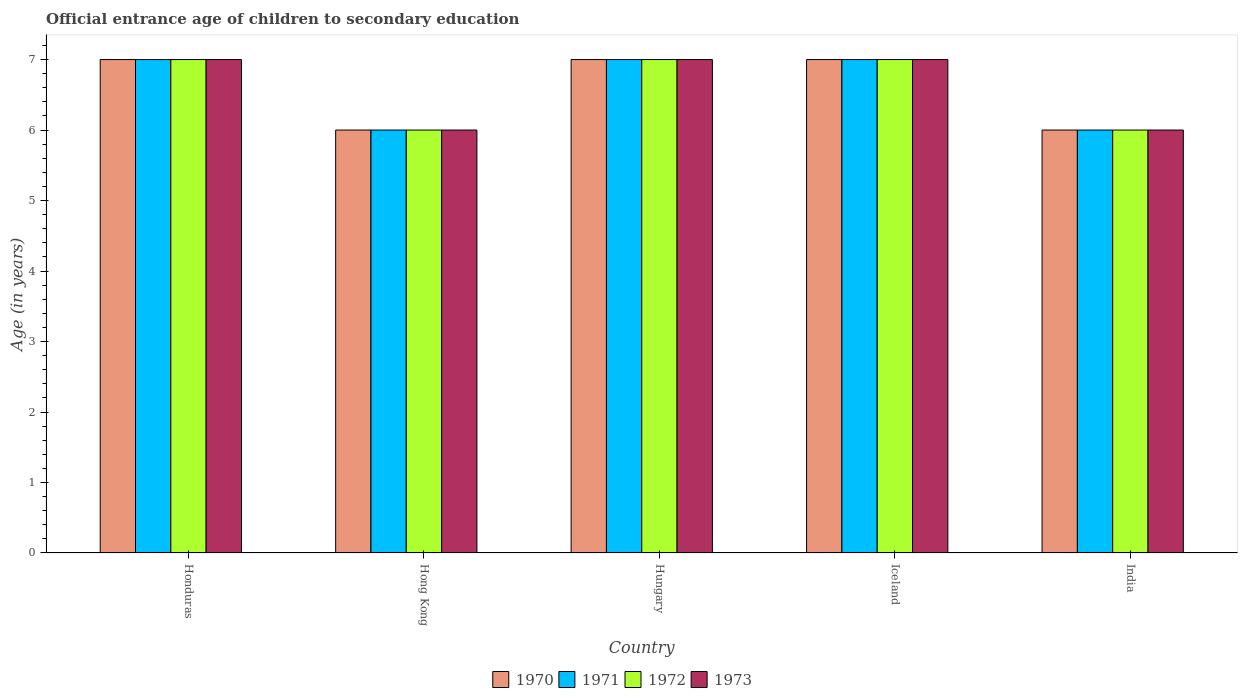How many different coloured bars are there?
Keep it short and to the point. 4. How many groups of bars are there?
Provide a short and direct response. 5. Are the number of bars per tick equal to the number of legend labels?
Give a very brief answer. Yes. How many bars are there on the 5th tick from the right?
Your response must be concise. 4. What is the label of the 1st group of bars from the left?
Give a very brief answer. Honduras. In how many cases, is the number of bars for a given country not equal to the number of legend labels?
Offer a very short reply. 0. What is the secondary school starting age of children in 1970 in Hungary?
Provide a short and direct response. 7. Across all countries, what is the maximum secondary school starting age of children in 1970?
Offer a very short reply. 7. Across all countries, what is the minimum secondary school starting age of children in 1971?
Your response must be concise. 6. In which country was the secondary school starting age of children in 1970 maximum?
Offer a very short reply. Honduras. In which country was the secondary school starting age of children in 1973 minimum?
Your answer should be very brief. Hong Kong. What is the total secondary school starting age of children in 1972 in the graph?
Offer a very short reply. 33. What is the difference between the secondary school starting age of children in 1972 in Hungary and that in India?
Your answer should be very brief. 1. What is the difference between the secondary school starting age of children in 1971 in Hungary and the secondary school starting age of children in 1972 in Hong Kong?
Offer a terse response. 1. What is the average secondary school starting age of children in 1972 per country?
Your answer should be compact. 6.6. In how many countries, is the secondary school starting age of children in 1972 greater than 2 years?
Offer a very short reply. 5. What is the ratio of the secondary school starting age of children in 1971 in Honduras to that in India?
Keep it short and to the point. 1.17. Is the secondary school starting age of children in 1972 in Honduras less than that in Iceland?
Keep it short and to the point. No. Is it the case that in every country, the sum of the secondary school starting age of children in 1973 and secondary school starting age of children in 1971 is greater than the sum of secondary school starting age of children in 1972 and secondary school starting age of children in 1970?
Make the answer very short. No. What does the 2nd bar from the left in Honduras represents?
Offer a very short reply. 1971. Does the graph contain any zero values?
Your answer should be compact. No. Does the graph contain grids?
Your response must be concise. No. How many legend labels are there?
Ensure brevity in your answer.  4. What is the title of the graph?
Provide a succinct answer. Official entrance age of children to secondary education. What is the label or title of the X-axis?
Provide a succinct answer. Country. What is the label or title of the Y-axis?
Offer a very short reply. Age (in years). What is the Age (in years) in 1970 in Honduras?
Your response must be concise. 7. What is the Age (in years) in 1972 in Honduras?
Your answer should be very brief. 7. What is the Age (in years) of 1970 in Hong Kong?
Provide a short and direct response. 6. What is the Age (in years) of 1973 in Hong Kong?
Offer a very short reply. 6. What is the Age (in years) of 1970 in Hungary?
Give a very brief answer. 7. What is the Age (in years) in 1970 in Iceland?
Your response must be concise. 7. What is the Age (in years) of 1972 in Iceland?
Keep it short and to the point. 7. What is the Age (in years) of 1971 in India?
Offer a terse response. 6. What is the Age (in years) in 1972 in India?
Offer a terse response. 6. What is the Age (in years) of 1973 in India?
Give a very brief answer. 6. Across all countries, what is the maximum Age (in years) in 1970?
Offer a very short reply. 7. Across all countries, what is the maximum Age (in years) in 1971?
Provide a short and direct response. 7. Across all countries, what is the maximum Age (in years) in 1973?
Your answer should be compact. 7. Across all countries, what is the minimum Age (in years) in 1970?
Your answer should be compact. 6. Across all countries, what is the minimum Age (in years) in 1971?
Provide a succinct answer. 6. Across all countries, what is the minimum Age (in years) in 1972?
Your answer should be compact. 6. Across all countries, what is the minimum Age (in years) of 1973?
Provide a short and direct response. 6. What is the total Age (in years) of 1970 in the graph?
Offer a very short reply. 33. What is the total Age (in years) of 1972 in the graph?
Your answer should be very brief. 33. What is the difference between the Age (in years) of 1970 in Honduras and that in Hong Kong?
Provide a short and direct response. 1. What is the difference between the Age (in years) of 1971 in Honduras and that in Hong Kong?
Offer a terse response. 1. What is the difference between the Age (in years) of 1972 in Honduras and that in Hong Kong?
Provide a short and direct response. 1. What is the difference between the Age (in years) in 1973 in Honduras and that in Hong Kong?
Make the answer very short. 1. What is the difference between the Age (in years) of 1970 in Honduras and that in Hungary?
Ensure brevity in your answer.  0. What is the difference between the Age (in years) of 1971 in Honduras and that in Hungary?
Offer a very short reply. 0. What is the difference between the Age (in years) of 1972 in Honduras and that in Hungary?
Keep it short and to the point. 0. What is the difference between the Age (in years) in 1973 in Honduras and that in Hungary?
Provide a short and direct response. 0. What is the difference between the Age (in years) in 1971 in Honduras and that in Iceland?
Your response must be concise. 0. What is the difference between the Age (in years) of 1972 in Honduras and that in India?
Keep it short and to the point. 1. What is the difference between the Age (in years) of 1973 in Honduras and that in India?
Give a very brief answer. 1. What is the difference between the Age (in years) of 1970 in Hong Kong and that in Hungary?
Give a very brief answer. -1. What is the difference between the Age (in years) in 1972 in Hong Kong and that in Hungary?
Your answer should be compact. -1. What is the difference between the Age (in years) of 1971 in Hong Kong and that in Iceland?
Keep it short and to the point. -1. What is the difference between the Age (in years) in 1972 in Hong Kong and that in Iceland?
Give a very brief answer. -1. What is the difference between the Age (in years) of 1973 in Hong Kong and that in Iceland?
Your answer should be very brief. -1. What is the difference between the Age (in years) of 1971 in Hong Kong and that in India?
Provide a short and direct response. 0. What is the difference between the Age (in years) of 1970 in Hungary and that in India?
Provide a succinct answer. 1. What is the difference between the Age (in years) of 1971 in Hungary and that in India?
Your answer should be compact. 1. What is the difference between the Age (in years) of 1973 in Hungary and that in India?
Provide a short and direct response. 1. What is the difference between the Age (in years) of 1970 in Iceland and that in India?
Your answer should be very brief. 1. What is the difference between the Age (in years) of 1972 in Iceland and that in India?
Offer a very short reply. 1. What is the difference between the Age (in years) in 1970 in Honduras and the Age (in years) in 1971 in Hong Kong?
Offer a very short reply. 1. What is the difference between the Age (in years) of 1970 in Honduras and the Age (in years) of 1972 in Hong Kong?
Provide a short and direct response. 1. What is the difference between the Age (in years) in 1970 in Honduras and the Age (in years) in 1971 in Iceland?
Your answer should be compact. 0. What is the difference between the Age (in years) in 1970 in Honduras and the Age (in years) in 1972 in Iceland?
Your answer should be very brief. 0. What is the difference between the Age (in years) in 1971 in Honduras and the Age (in years) in 1972 in Iceland?
Your answer should be compact. 0. What is the difference between the Age (in years) of 1971 in Honduras and the Age (in years) of 1973 in Iceland?
Provide a short and direct response. 0. What is the difference between the Age (in years) of 1970 in Honduras and the Age (in years) of 1973 in India?
Ensure brevity in your answer.  1. What is the difference between the Age (in years) of 1971 in Honduras and the Age (in years) of 1972 in India?
Provide a short and direct response. 1. What is the difference between the Age (in years) of 1971 in Honduras and the Age (in years) of 1973 in India?
Provide a short and direct response. 1. What is the difference between the Age (in years) in 1972 in Honduras and the Age (in years) in 1973 in India?
Your answer should be very brief. 1. What is the difference between the Age (in years) in 1970 in Hong Kong and the Age (in years) in 1971 in Hungary?
Give a very brief answer. -1. What is the difference between the Age (in years) in 1971 in Hong Kong and the Age (in years) in 1972 in Hungary?
Give a very brief answer. -1. What is the difference between the Age (in years) of 1972 in Hong Kong and the Age (in years) of 1973 in Hungary?
Your answer should be very brief. -1. What is the difference between the Age (in years) in 1970 in Hong Kong and the Age (in years) in 1973 in Iceland?
Give a very brief answer. -1. What is the difference between the Age (in years) of 1972 in Hong Kong and the Age (in years) of 1973 in Iceland?
Give a very brief answer. -1. What is the difference between the Age (in years) in 1970 in Hong Kong and the Age (in years) in 1972 in India?
Keep it short and to the point. 0. What is the difference between the Age (in years) in 1970 in Hong Kong and the Age (in years) in 1973 in India?
Provide a short and direct response. 0. What is the difference between the Age (in years) of 1971 in Hong Kong and the Age (in years) of 1972 in India?
Your answer should be very brief. 0. What is the difference between the Age (in years) in 1970 in Hungary and the Age (in years) in 1971 in Iceland?
Provide a succinct answer. 0. What is the difference between the Age (in years) in 1970 in Hungary and the Age (in years) in 1972 in Iceland?
Offer a terse response. 0. What is the difference between the Age (in years) of 1971 in Hungary and the Age (in years) of 1972 in Iceland?
Your answer should be very brief. 0. What is the difference between the Age (in years) in 1970 in Hungary and the Age (in years) in 1971 in India?
Make the answer very short. 1. What is the difference between the Age (in years) in 1970 in Hungary and the Age (in years) in 1972 in India?
Your answer should be compact. 1. What is the difference between the Age (in years) of 1970 in Iceland and the Age (in years) of 1971 in India?
Your answer should be compact. 1. What is the difference between the Age (in years) in 1970 in Iceland and the Age (in years) in 1972 in India?
Offer a terse response. 1. What is the average Age (in years) of 1970 per country?
Offer a terse response. 6.6. What is the difference between the Age (in years) in 1970 and Age (in years) in 1971 in Honduras?
Offer a terse response. 0. What is the difference between the Age (in years) of 1970 and Age (in years) of 1973 in Honduras?
Provide a succinct answer. 0. What is the difference between the Age (in years) in 1971 and Age (in years) in 1973 in Honduras?
Provide a succinct answer. 0. What is the difference between the Age (in years) of 1970 and Age (in years) of 1973 in Hong Kong?
Ensure brevity in your answer.  0. What is the difference between the Age (in years) in 1971 and Age (in years) in 1973 in Hong Kong?
Your answer should be very brief. 0. What is the difference between the Age (in years) in 1972 and Age (in years) in 1973 in Hong Kong?
Offer a very short reply. 0. What is the difference between the Age (in years) in 1971 and Age (in years) in 1972 in Hungary?
Offer a very short reply. 0. What is the difference between the Age (in years) in 1971 and Age (in years) in 1973 in Hungary?
Your answer should be very brief. 0. What is the difference between the Age (in years) of 1972 and Age (in years) of 1973 in Hungary?
Keep it short and to the point. 0. What is the difference between the Age (in years) of 1970 and Age (in years) of 1971 in Iceland?
Your response must be concise. 0. What is the difference between the Age (in years) in 1970 and Age (in years) in 1972 in Iceland?
Offer a very short reply. 0. What is the difference between the Age (in years) of 1970 and Age (in years) of 1973 in Iceland?
Offer a terse response. 0. What is the difference between the Age (in years) in 1971 and Age (in years) in 1972 in Iceland?
Your answer should be compact. 0. What is the difference between the Age (in years) of 1971 and Age (in years) of 1973 in Iceland?
Give a very brief answer. 0. What is the difference between the Age (in years) of 1970 and Age (in years) of 1971 in India?
Offer a very short reply. 0. What is the difference between the Age (in years) of 1971 and Age (in years) of 1972 in India?
Offer a very short reply. 0. What is the difference between the Age (in years) of 1972 and Age (in years) of 1973 in India?
Give a very brief answer. 0. What is the ratio of the Age (in years) in 1972 in Honduras to that in Hungary?
Your answer should be compact. 1. What is the ratio of the Age (in years) in 1973 in Honduras to that in Hungary?
Your response must be concise. 1. What is the ratio of the Age (in years) in 1972 in Honduras to that in Iceland?
Your response must be concise. 1. What is the ratio of the Age (in years) of 1970 in Honduras to that in India?
Provide a short and direct response. 1.17. What is the ratio of the Age (in years) in 1971 in Honduras to that in India?
Ensure brevity in your answer.  1.17. What is the ratio of the Age (in years) of 1972 in Honduras to that in India?
Your response must be concise. 1.17. What is the ratio of the Age (in years) in 1970 in Hong Kong to that in Hungary?
Your answer should be compact. 0.86. What is the ratio of the Age (in years) in 1972 in Hong Kong to that in Hungary?
Provide a short and direct response. 0.86. What is the ratio of the Age (in years) in 1971 in Hong Kong to that in Iceland?
Give a very brief answer. 0.86. What is the ratio of the Age (in years) of 1972 in Hong Kong to that in Iceland?
Your response must be concise. 0.86. What is the ratio of the Age (in years) of 1973 in Hong Kong to that in India?
Offer a terse response. 1. What is the ratio of the Age (in years) in 1971 in Hungary to that in Iceland?
Give a very brief answer. 1. What is the ratio of the Age (in years) in 1973 in Hungary to that in Iceland?
Your answer should be compact. 1. What is the ratio of the Age (in years) of 1971 in Hungary to that in India?
Ensure brevity in your answer.  1.17. What is the ratio of the Age (in years) in 1972 in Hungary to that in India?
Your response must be concise. 1.17. What is the ratio of the Age (in years) in 1973 in Hungary to that in India?
Your answer should be compact. 1.17. What is the ratio of the Age (in years) in 1971 in Iceland to that in India?
Your answer should be very brief. 1.17. What is the ratio of the Age (in years) of 1972 in Iceland to that in India?
Provide a short and direct response. 1.17. What is the ratio of the Age (in years) in 1973 in Iceland to that in India?
Give a very brief answer. 1.17. What is the difference between the highest and the second highest Age (in years) of 1972?
Make the answer very short. 0. What is the difference between the highest and the second highest Age (in years) in 1973?
Your answer should be compact. 0. What is the difference between the highest and the lowest Age (in years) in 1970?
Offer a very short reply. 1. 